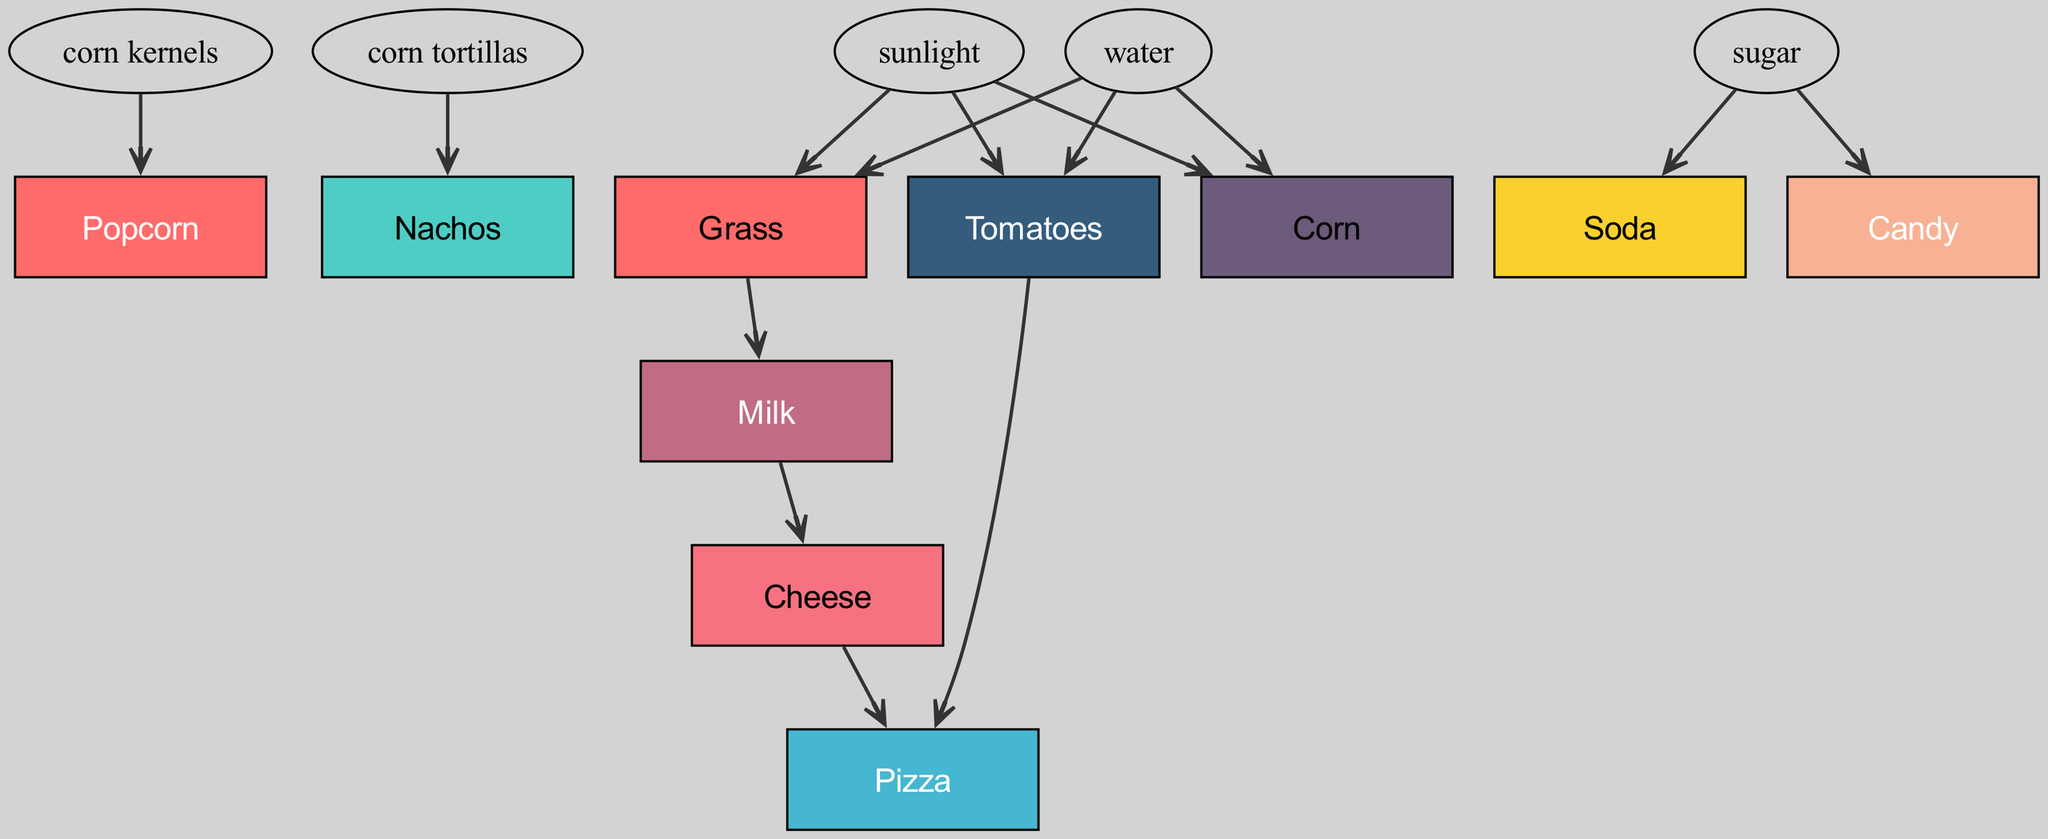What snack food consumes cheese? The diagram shows that the only snack food that consumes cheese is Pizza. By checking the edges that lead from the node "Cheese" to the snack foods, we find that "Pizza" is connected.
Answer: Pizza How many snack foods are present in the diagram? The total number of snack foods represented in the diagram can be counted by listing the unique snack food nodes. The elements listed are Popcorn, Nachos, Pizza, Soda, and Candy, totaling to five distinct snack foods.
Answer: 5 Which nodes consume corn kernels? From the diagram, it is evident that Popcorn is the only snack food that directly consumes corn kernels, as shown by the edge leading from the node "corn kernels" to "Popcorn".
Answer: Popcorn Which snack foods share the same source, sugar? The diagram illustrates that both Soda and Candy are consuming sugar, since there are edges leading to these snack foods from the "sugar" node. Thus, they share sugar as a common source.
Answer: Soda and Candy What is the result of combining the sources for Nachos and Pizza? To determine the combined sources, we examine the sources for both Nachos and Pizza. Nachos consume corn tortillas and Pizza consumes cheese and tomatoes. The sources are corn tortillas, cheese, and tomatoes.
Answer: Corn tortillas, cheese, and tomatoes Which food sources have a direct connection to both Pizza and Popcorn? By analyzing the connections, we see that neither food source has a direct common connection to both Pizza and Popcorn. The sources we identify for both snacks are different, with Popcorn consuming corn and Pizza consuming cheese, among others.
Answer: None Which snack foods consume milk? Referring to the diagram, Cheese is the only snack food that indirectly consumes milk through the edge from the "milk" node. However, since Cheese is not a snack food final node, we realize that actually, none of the listed snack foods directly uses milk.
Answer: None What is the total number of unique food sources represented in the diagram? To find the number of unique food sources, we extract the food sources presented: sunlight, water, grass, milk, corn kernels, sugar, cheese, and tomatoes. Counting these, we have eight unique food sources total.
Answer: 8 Which snack food is at the top of the food chain with no inputs? The food chain shows that popcorn has no inputs leading to it; thus, it sits at the top of the chain due to being produced from corn kernels. Other snack foods have sources contributing to their existence.
Answer: Popcorn 